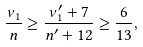<formula> <loc_0><loc_0><loc_500><loc_500>\frac { \nu _ { 1 } } { n } \geq \frac { \nu ^ { \prime } _ { 1 } + 7 } { n ^ { \prime } + 1 2 } \geq \frac { 6 } { 1 3 } ,</formula> 